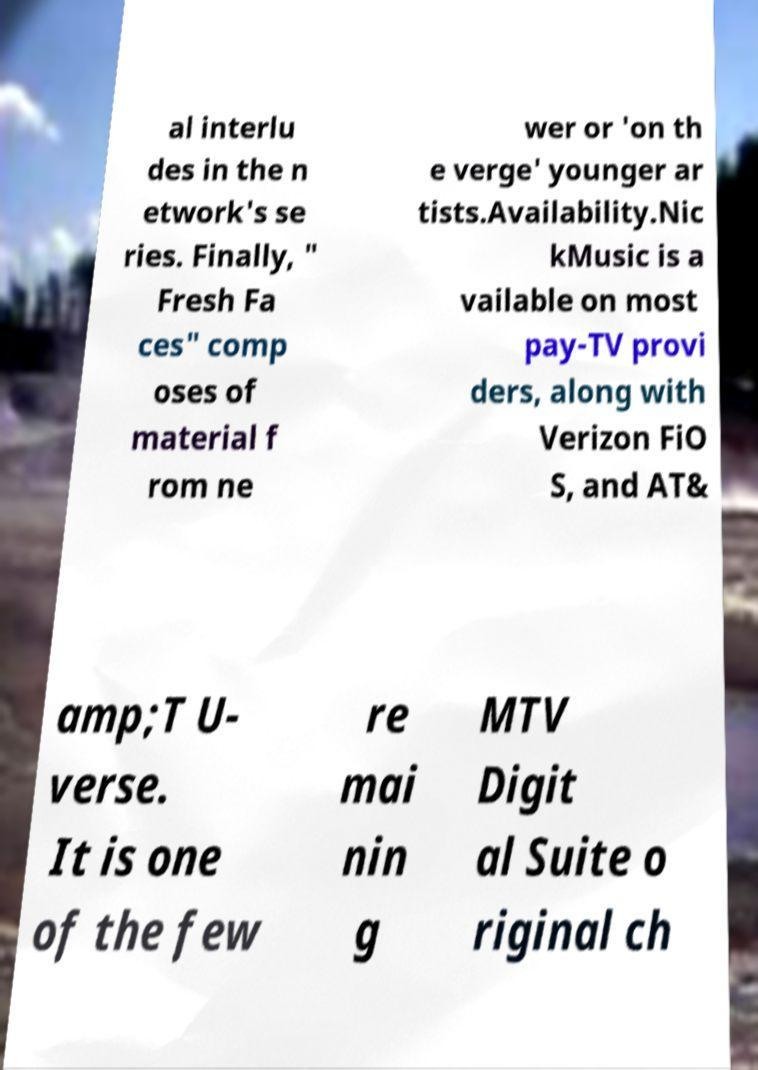Please identify and transcribe the text found in this image. al interlu des in the n etwork's se ries. Finally, " Fresh Fa ces" comp oses of material f rom ne wer or 'on th e verge' younger ar tists.Availability.Nic kMusic is a vailable on most pay-TV provi ders, along with Verizon FiO S, and AT& amp;T U- verse. It is one of the few re mai nin g MTV Digit al Suite o riginal ch 